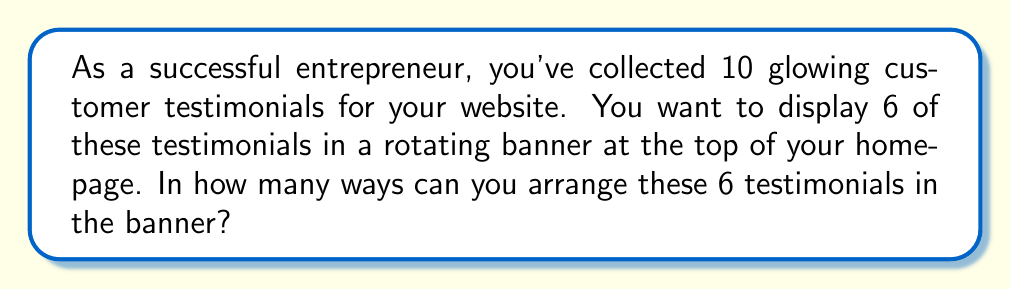Provide a solution to this math problem. Let's approach this step-by-step:

1) First, we need to select 6 testimonials out of the 10 available. This is a combination problem.

2) After selecting the 6 testimonials, we need to arrange them in a specific order in the banner. This is a permutation problem.

3) For the selection step, we use the combination formula:
   $${10 \choose 6} = \frac{10!}{6!(10-6)!} = \frac{10!}{6!4!}$$

4) For the arrangement step, we use the permutation formula:
   $$P(6,6) = 6!$$

5) By the multiplication principle, we multiply these two results:

   $$\text{Total arrangements} = {10 \choose 6} \times 6!$$

6) Let's calculate:
   $${10 \choose 6} = \frac{10!}{6!4!} = \frac{10 \times 9 \times 8 \times 7}{4 \times 3 \times 2 \times 1} = 210$$

7) Now, multiply by 6!:
   $$210 \times 6! = 210 \times 720 = 151,200$$

Therefore, there are 151,200 ways to arrange 6 testimonials out of 10 in the banner.
Answer: 151,200 